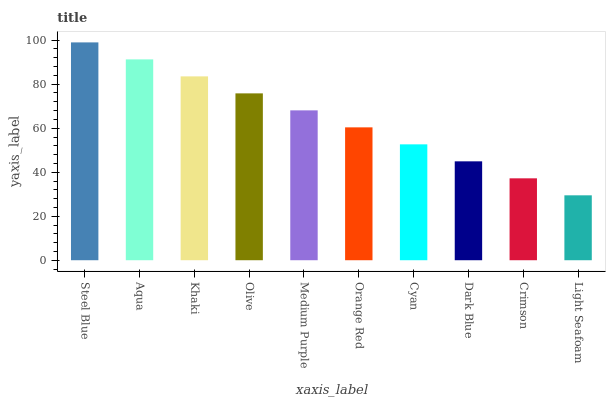Is Light Seafoam the minimum?
Answer yes or no. Yes. Is Steel Blue the maximum?
Answer yes or no. Yes. Is Aqua the minimum?
Answer yes or no. No. Is Aqua the maximum?
Answer yes or no. No. Is Steel Blue greater than Aqua?
Answer yes or no. Yes. Is Aqua less than Steel Blue?
Answer yes or no. Yes. Is Aqua greater than Steel Blue?
Answer yes or no. No. Is Steel Blue less than Aqua?
Answer yes or no. No. Is Medium Purple the high median?
Answer yes or no. Yes. Is Orange Red the low median?
Answer yes or no. Yes. Is Dark Blue the high median?
Answer yes or no. No. Is Crimson the low median?
Answer yes or no. No. 